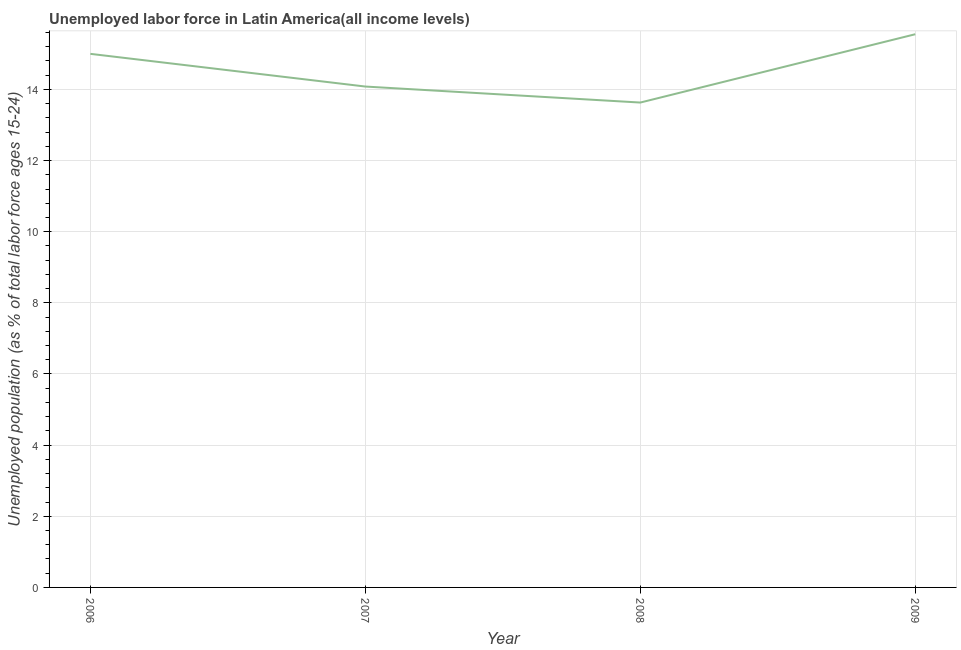What is the total unemployed youth population in 2006?
Your answer should be very brief. 15. Across all years, what is the maximum total unemployed youth population?
Your answer should be very brief. 15.55. Across all years, what is the minimum total unemployed youth population?
Ensure brevity in your answer.  13.63. In which year was the total unemployed youth population maximum?
Offer a very short reply. 2009. What is the sum of the total unemployed youth population?
Give a very brief answer. 58.26. What is the difference between the total unemployed youth population in 2008 and 2009?
Keep it short and to the point. -1.92. What is the average total unemployed youth population per year?
Provide a short and direct response. 14.57. What is the median total unemployed youth population?
Offer a terse response. 14.54. In how many years, is the total unemployed youth population greater than 11.6 %?
Give a very brief answer. 4. What is the ratio of the total unemployed youth population in 2006 to that in 2009?
Offer a very short reply. 0.96. What is the difference between the highest and the second highest total unemployed youth population?
Give a very brief answer. 0.55. What is the difference between the highest and the lowest total unemployed youth population?
Give a very brief answer. 1.92. In how many years, is the total unemployed youth population greater than the average total unemployed youth population taken over all years?
Provide a short and direct response. 2. Does the total unemployed youth population monotonically increase over the years?
Your answer should be compact. No. How many lines are there?
Your response must be concise. 1. Does the graph contain any zero values?
Your answer should be very brief. No. What is the title of the graph?
Keep it short and to the point. Unemployed labor force in Latin America(all income levels). What is the label or title of the Y-axis?
Make the answer very short. Unemployed population (as % of total labor force ages 15-24). What is the Unemployed population (as % of total labor force ages 15-24) of 2006?
Your answer should be very brief. 15. What is the Unemployed population (as % of total labor force ages 15-24) of 2007?
Give a very brief answer. 14.08. What is the Unemployed population (as % of total labor force ages 15-24) of 2008?
Ensure brevity in your answer.  13.63. What is the Unemployed population (as % of total labor force ages 15-24) in 2009?
Keep it short and to the point. 15.55. What is the difference between the Unemployed population (as % of total labor force ages 15-24) in 2006 and 2007?
Give a very brief answer. 0.92. What is the difference between the Unemployed population (as % of total labor force ages 15-24) in 2006 and 2008?
Ensure brevity in your answer.  1.37. What is the difference between the Unemployed population (as % of total labor force ages 15-24) in 2006 and 2009?
Make the answer very short. -0.55. What is the difference between the Unemployed population (as % of total labor force ages 15-24) in 2007 and 2008?
Your response must be concise. 0.45. What is the difference between the Unemployed population (as % of total labor force ages 15-24) in 2007 and 2009?
Make the answer very short. -1.47. What is the difference between the Unemployed population (as % of total labor force ages 15-24) in 2008 and 2009?
Provide a succinct answer. -1.92. What is the ratio of the Unemployed population (as % of total labor force ages 15-24) in 2006 to that in 2007?
Keep it short and to the point. 1.06. What is the ratio of the Unemployed population (as % of total labor force ages 15-24) in 2006 to that in 2008?
Your answer should be compact. 1.1. What is the ratio of the Unemployed population (as % of total labor force ages 15-24) in 2006 to that in 2009?
Make the answer very short. 0.96. What is the ratio of the Unemployed population (as % of total labor force ages 15-24) in 2007 to that in 2008?
Your response must be concise. 1.03. What is the ratio of the Unemployed population (as % of total labor force ages 15-24) in 2007 to that in 2009?
Make the answer very short. 0.91. What is the ratio of the Unemployed population (as % of total labor force ages 15-24) in 2008 to that in 2009?
Give a very brief answer. 0.88. 